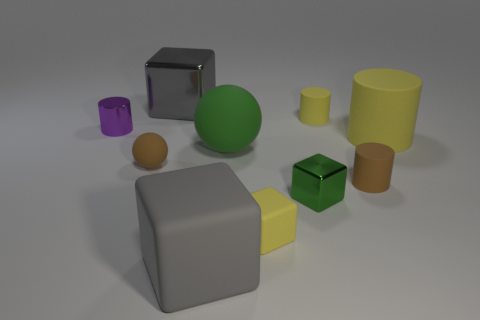What time of day do you think this image represents? The image does not provide clear indications of the time of day, as it seems to be a controlled lighting environment, likely indoors, where objects are illuminated uniformly from above without any signs of natural light that could suggest a time of day. 